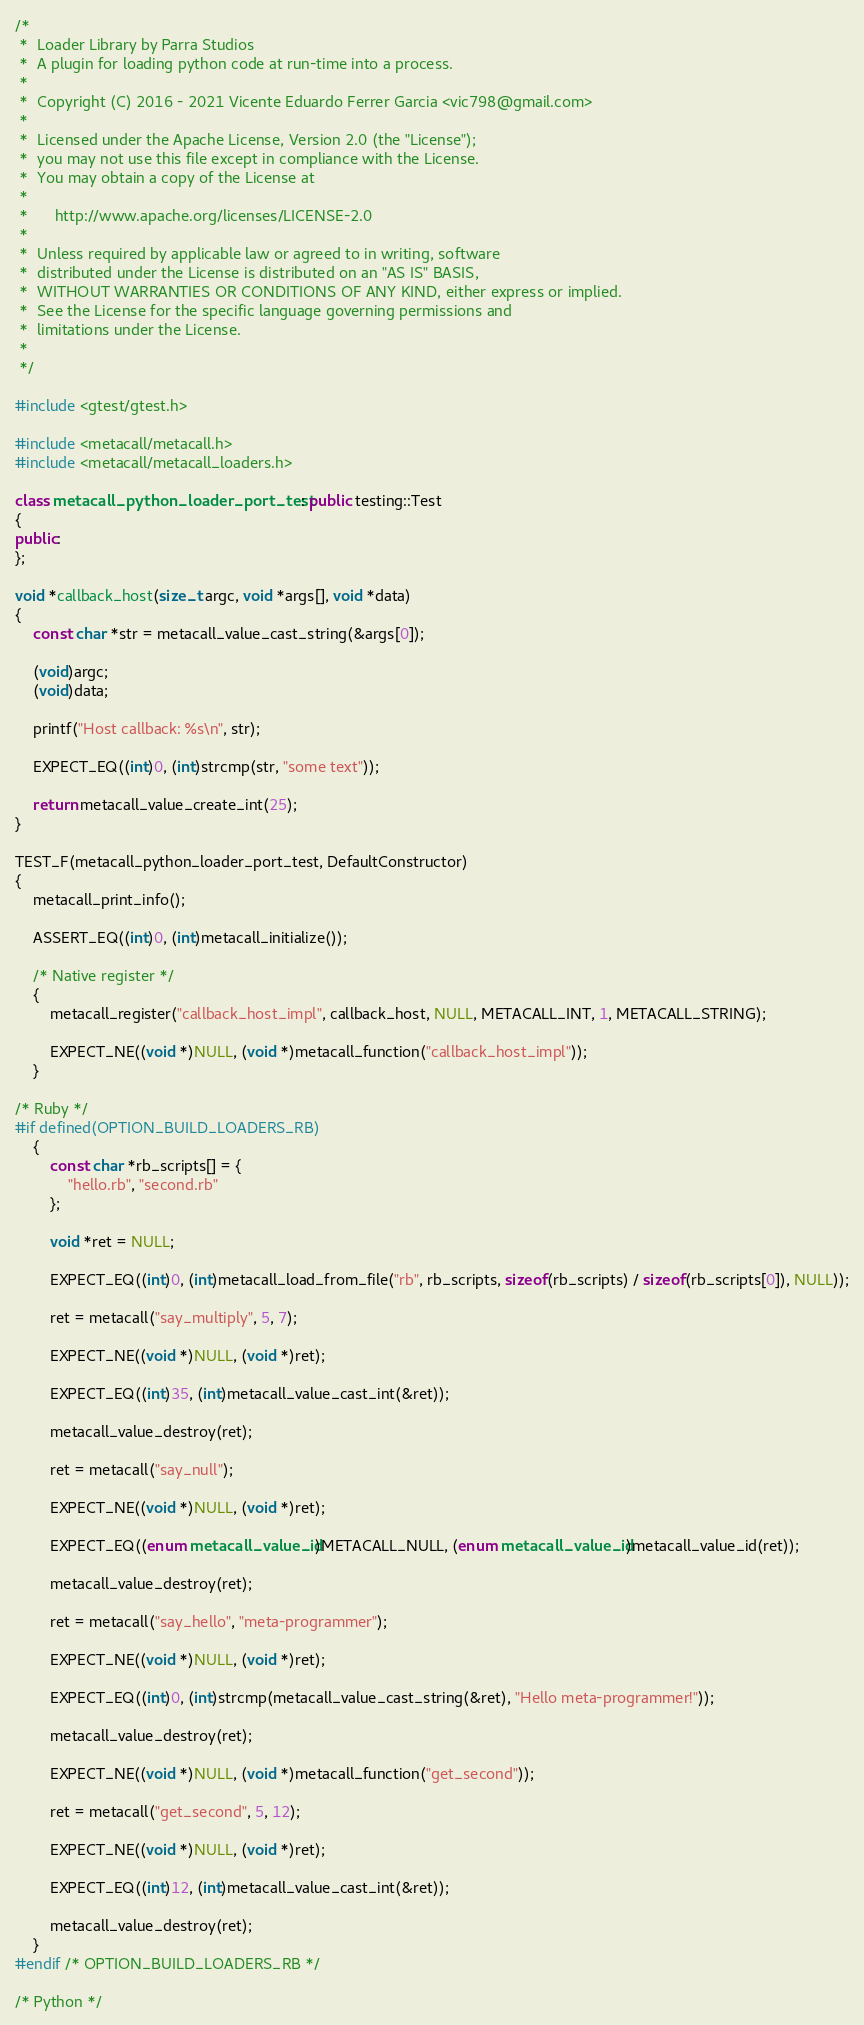<code> <loc_0><loc_0><loc_500><loc_500><_C++_>/*
 *	Loader Library by Parra Studios
 *	A plugin for loading python code at run-time into a process.
 *
 *	Copyright (C) 2016 - 2021 Vicente Eduardo Ferrer Garcia <vic798@gmail.com>
 *
 *	Licensed under the Apache License, Version 2.0 (the "License");
 *	you may not use this file except in compliance with the License.
 *	You may obtain a copy of the License at
 *
 *		http://www.apache.org/licenses/LICENSE-2.0
 *
 *	Unless required by applicable law or agreed to in writing, software
 *	distributed under the License is distributed on an "AS IS" BASIS,
 *	WITHOUT WARRANTIES OR CONDITIONS OF ANY KIND, either express or implied.
 *	See the License for the specific language governing permissions and
 *	limitations under the License.
 *
 */

#include <gtest/gtest.h>

#include <metacall/metacall.h>
#include <metacall/metacall_loaders.h>

class metacall_python_loader_port_test : public testing::Test
{
public:
};

void *callback_host(size_t argc, void *args[], void *data)
{
	const char *str = metacall_value_cast_string(&args[0]);

	(void)argc;
	(void)data;

	printf("Host callback: %s\n", str);

	EXPECT_EQ((int)0, (int)strcmp(str, "some text"));

	return metacall_value_create_int(25);
}

TEST_F(metacall_python_loader_port_test, DefaultConstructor)
{
	metacall_print_info();

	ASSERT_EQ((int)0, (int)metacall_initialize());

	/* Native register */
	{
		metacall_register("callback_host_impl", callback_host, NULL, METACALL_INT, 1, METACALL_STRING);

		EXPECT_NE((void *)NULL, (void *)metacall_function("callback_host_impl"));
	}

/* Ruby */
#if defined(OPTION_BUILD_LOADERS_RB)
	{
		const char *rb_scripts[] = {
			"hello.rb", "second.rb"
		};

		void *ret = NULL;

		EXPECT_EQ((int)0, (int)metacall_load_from_file("rb", rb_scripts, sizeof(rb_scripts) / sizeof(rb_scripts[0]), NULL));

		ret = metacall("say_multiply", 5, 7);

		EXPECT_NE((void *)NULL, (void *)ret);

		EXPECT_EQ((int)35, (int)metacall_value_cast_int(&ret));

		metacall_value_destroy(ret);

		ret = metacall("say_null");

		EXPECT_NE((void *)NULL, (void *)ret);

		EXPECT_EQ((enum metacall_value_id)METACALL_NULL, (enum metacall_value_id)metacall_value_id(ret));

		metacall_value_destroy(ret);

		ret = metacall("say_hello", "meta-programmer");

		EXPECT_NE((void *)NULL, (void *)ret);

		EXPECT_EQ((int)0, (int)strcmp(metacall_value_cast_string(&ret), "Hello meta-programmer!"));

		metacall_value_destroy(ret);

		EXPECT_NE((void *)NULL, (void *)metacall_function("get_second"));

		ret = metacall("get_second", 5, 12);

		EXPECT_NE((void *)NULL, (void *)ret);

		EXPECT_EQ((int)12, (int)metacall_value_cast_int(&ret));

		metacall_value_destroy(ret);
	}
#endif /* OPTION_BUILD_LOADERS_RB */

/* Python */</code> 